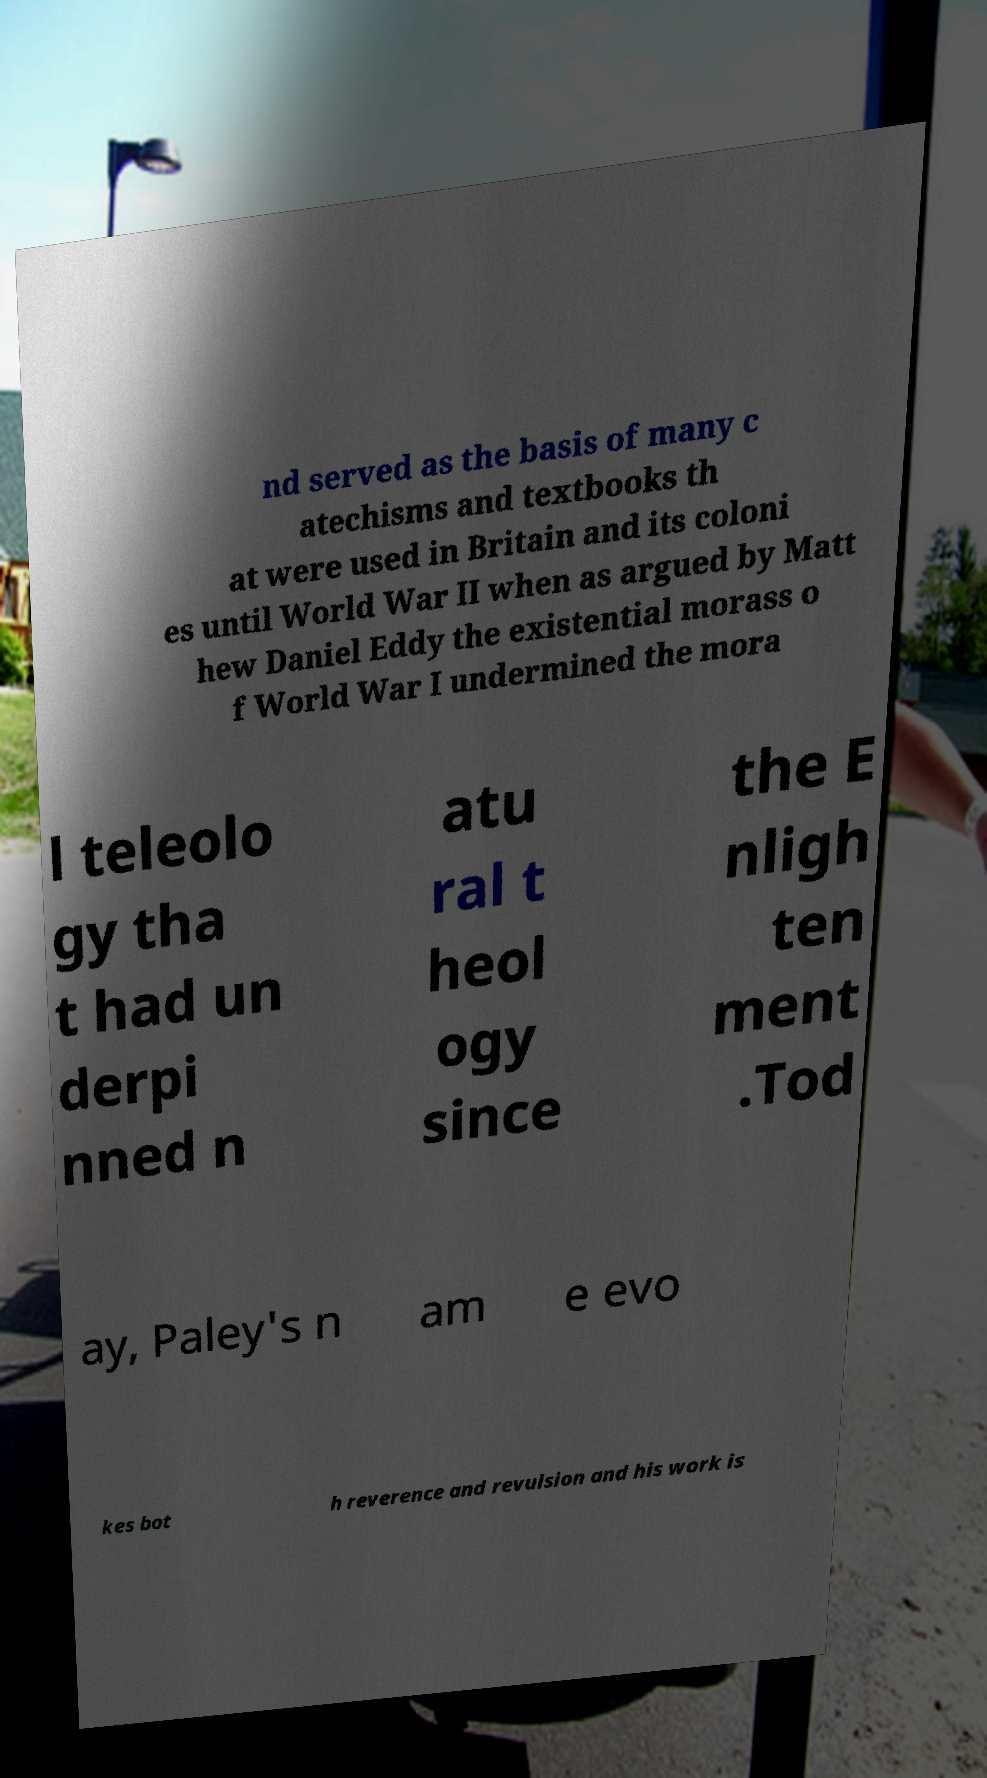What messages or text are displayed in this image? I need them in a readable, typed format. nd served as the basis of many c atechisms and textbooks th at were used in Britain and its coloni es until World War II when as argued by Matt hew Daniel Eddy the existential morass o f World War I undermined the mora l teleolo gy tha t had un derpi nned n atu ral t heol ogy since the E nligh ten ment .Tod ay, Paley's n am e evo kes bot h reverence and revulsion and his work is 